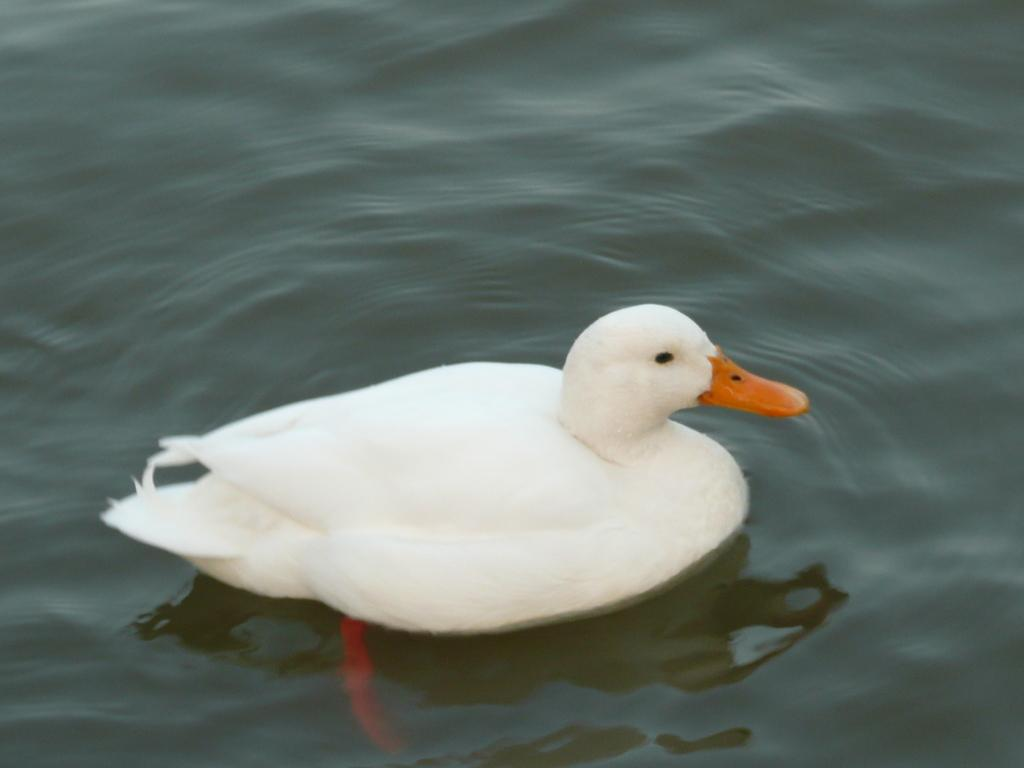What type of animal is in the image? There is a duck in the image. What is the primary element in which the duck is situated? There is water visible in the image, and the duck is in it. What type of letter is being delivered by the duck in the image? There is no letter present in the image, and the duck is not delivering anything. 